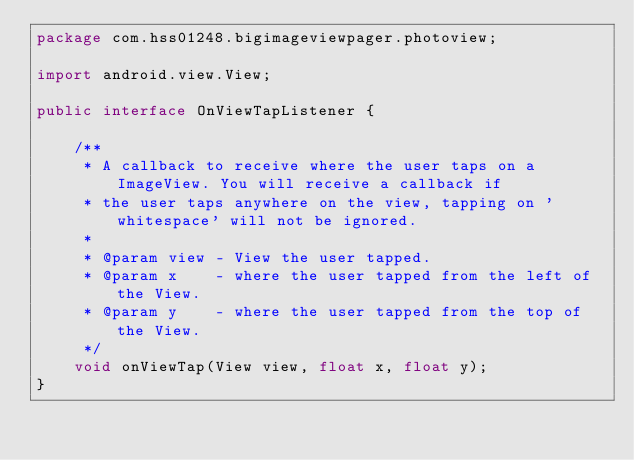Convert code to text. <code><loc_0><loc_0><loc_500><loc_500><_Java_>package com.hss01248.bigimageviewpager.photoview;

import android.view.View;

public interface OnViewTapListener {

    /**
     * A callback to receive where the user taps on a ImageView. You will receive a callback if
     * the user taps anywhere on the view, tapping on 'whitespace' will not be ignored.
     *
     * @param view - View the user tapped.
     * @param x    - where the user tapped from the left of the View.
     * @param y    - where the user tapped from the top of the View.
     */
    void onViewTap(View view, float x, float y);
}
</code> 